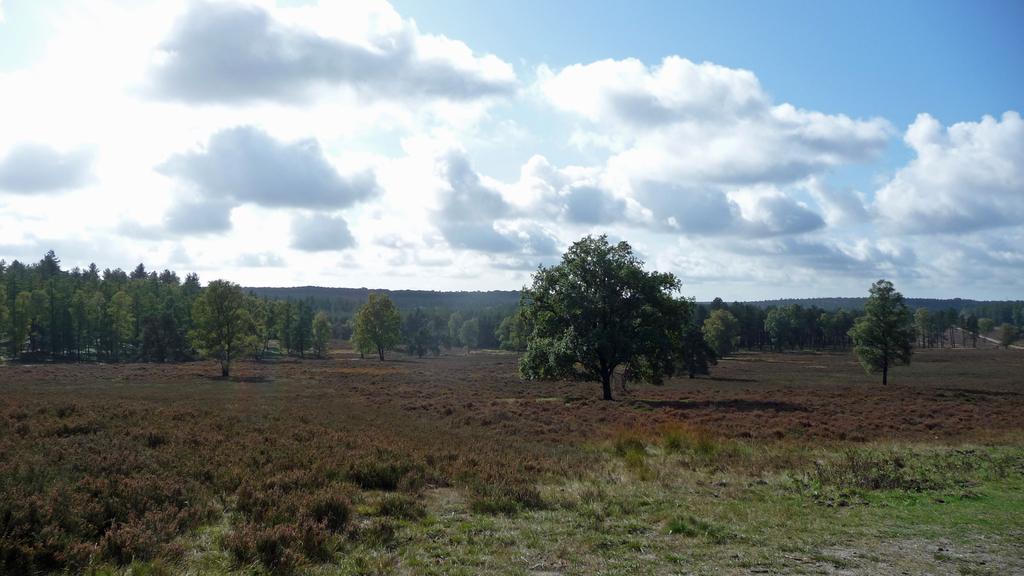Please provide a concise description of this image. In the foreground of the picture there are shrubs and grass. In the center of the picture there are trees and shrubs. Sky is sunny. 